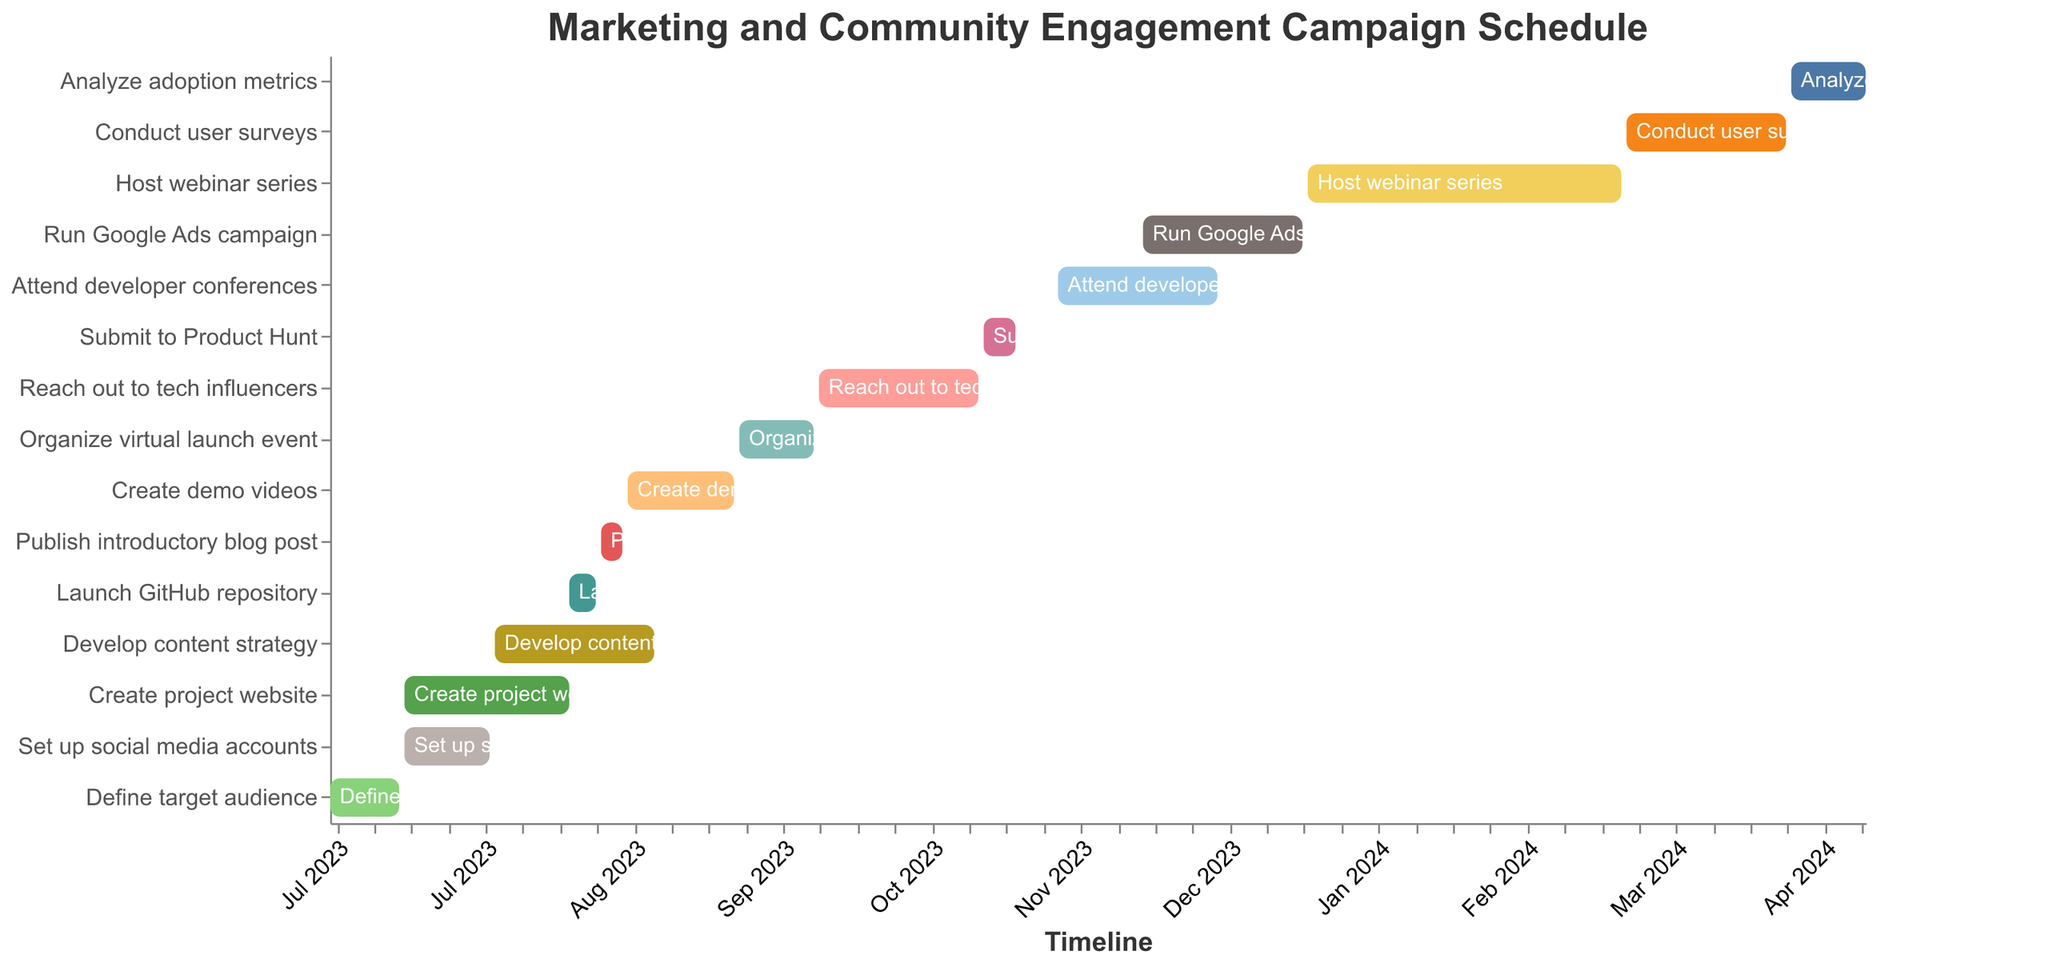Which task has the earliest start date? The earliest start date can be found by examining the "Start Date" for each task and identifying the one that begins first. "Define target audience" starts on 2023-07-01, which is the earliest.
Answer: Define target audience Which tasks overlap in the month of August 2023? To find overlapping tasks in August 2023, look at tasks that span any part of August. These tasks include "Create project website", "Set up social media accounts", "Develop content strategy", "Launch GitHub repository", "Publish introductory blog post", "Create demo videos".
Answer: Create project website, Develop content strategy, Launch GitHub repository, Publish introductory blog post, Create demo videos Which task has the longest duration? To determine the longest duration, calculate the duration of each task by subtracting the start date from the end date. "Host webinar series" spans from 2024-01-01 to 2024-02-29, covering 59 days, making it the longest.
Answer: Host webinar series What is the total number of tasks scheduled for 2023? Count the tasks that both start and end within the year 2023. There are 11 tasks: Define target audience, Create project website, Set up social media accounts, Develop content strategy, Launch GitHub repository, Publish introductory blog post, Create demo videos, Organize virtual launch event, Reach out to tech influencers, Submit to Product Hunt, Run Google Ads campaign.
Answer: 11 How many tasks end in November 2023? Count the tasks with an end date that falls within November 2023. Only "Submit to Product Hunt" ends in November 2023, specifically on 2023-11-07.
Answer: 1 What tasks are scheduled concurrently with "Attend developer conferences"? Identify overlapping periods with "Attend developer conferences" from 2023-11-15 to 2023-12-15. The "Run Google Ads campaign" from 2023-12-01 to 2023-12-31 overlaps this period.
Answer: Run Google Ads campaign When does the task "Analyze adoption metrics" end? The end date of "Analyze adoption metrics" can be directly found by referencing the figure. It ends on 2024-04-15.
Answer: 2024-04-15 Compare the durations of "Reach out to tech influencers" and "Conduct user surveys". Which one is longer? Calculate durations by finding the difference between start and end dates for both tasks. "Reach out to tech influencers" spans 30 days (2023-10-01 to 2023-10-31), while "Conduct user surveys" spans 31 days (2024-03-01 to 2024-03-31). "Conduct user surveys" is longer.
Answer: Conduct user surveys What is the interval between the end of "Create demo videos" and the start of "Organize virtual launch event"? Subtract the end date of "Create demo videos" (2023-09-15) from the start date of "Organize virtual launch event" (2023-09-16). The interval is 1 day.
Answer: 1 day 